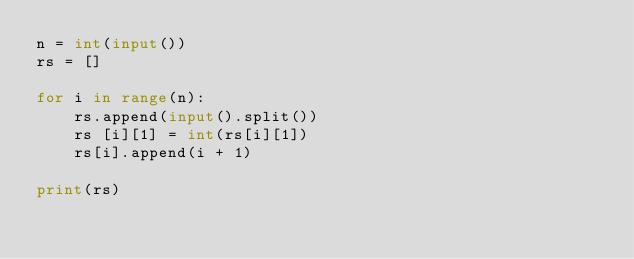<code> <loc_0><loc_0><loc_500><loc_500><_Python_>n = int(input())
rs = []

for i in range(n):
  	rs.append(input().split())
    rs [i][1] = int(rs[i][1])
    rs[i].append(i + 1)

print(rs)</code> 